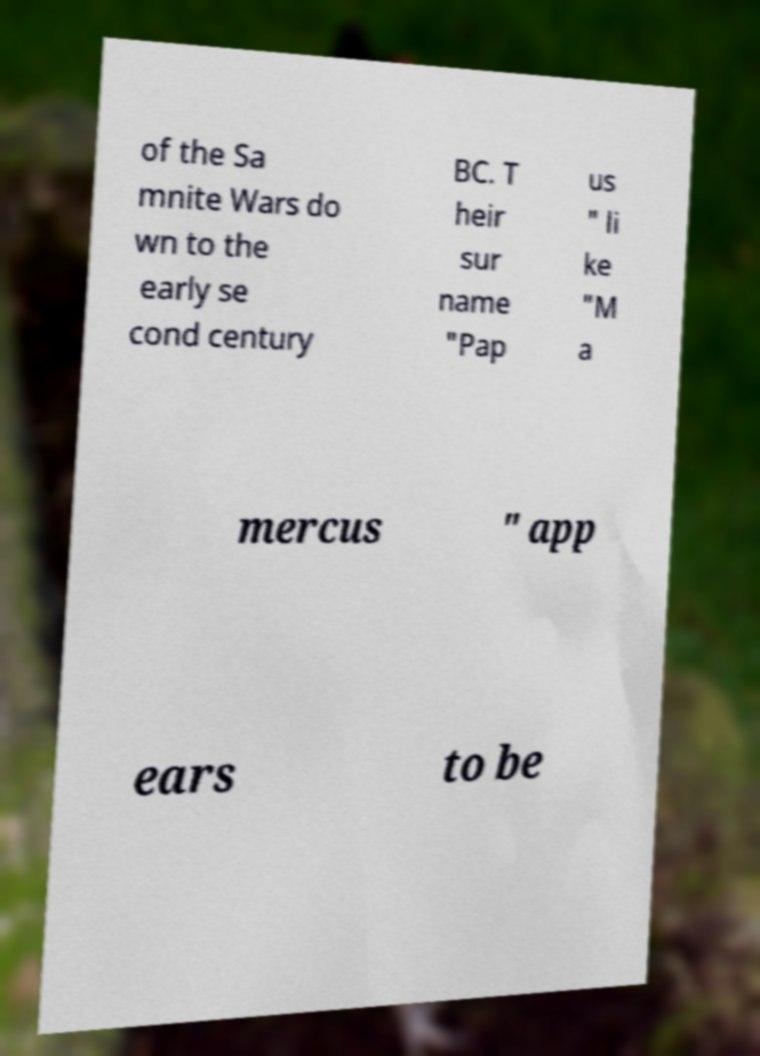Please identify and transcribe the text found in this image. of the Sa mnite Wars do wn to the early se cond century BC. T heir sur name "Pap us " li ke "M a mercus " app ears to be 